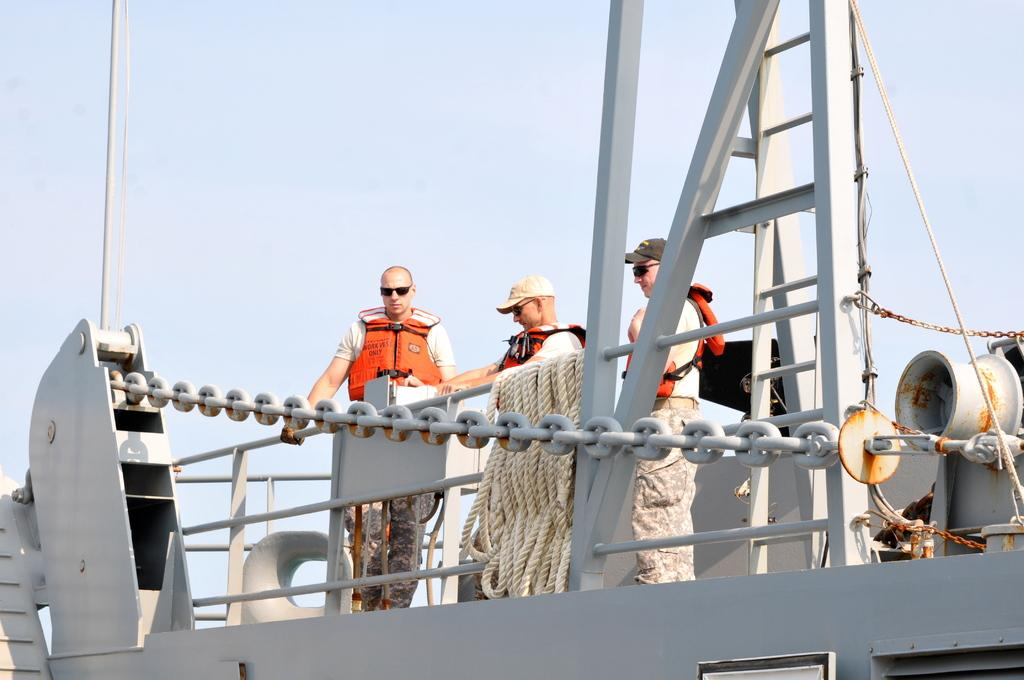What type of vehicle is in the image? There are people on a ship in the image. What are some people wearing on their heads? Some people are wearing caps in the image. What material is used for the rods in the image? The rods in the image are made of metal. What is used for tying or securing in the image? A rope and a chain are visible in the image. What type of patch is visible on the jeans of the person standing on the left side of the image? There are no jeans or patches present in the image; it features a ship with people and various objects. 